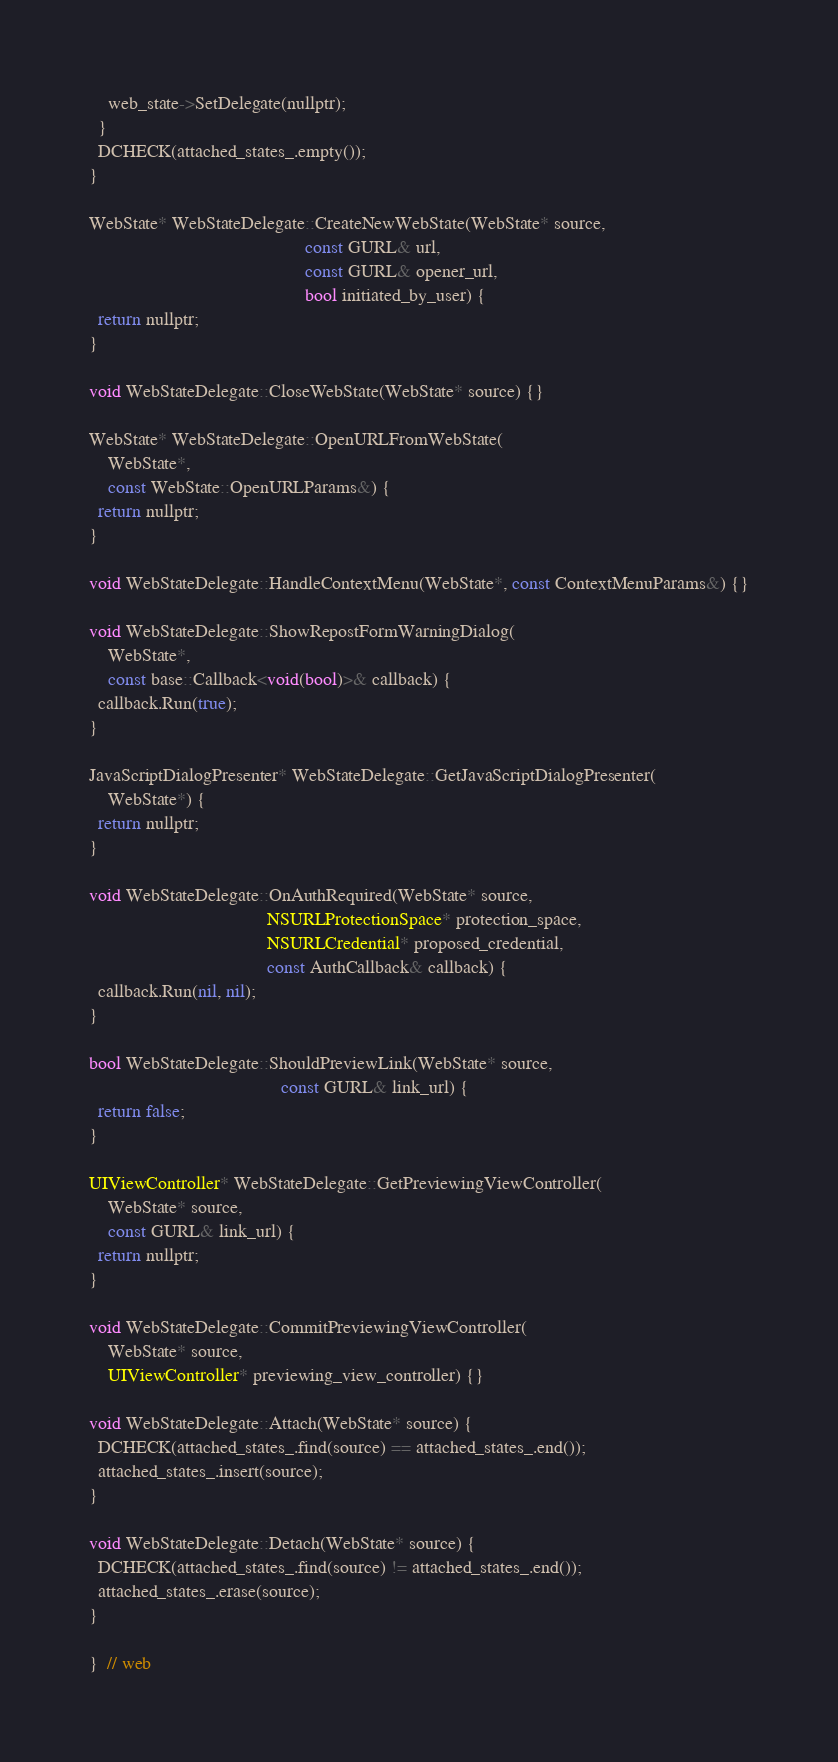Convert code to text. <code><loc_0><loc_0><loc_500><loc_500><_ObjectiveC_>    web_state->SetDelegate(nullptr);
  }
  DCHECK(attached_states_.empty());
}

WebState* WebStateDelegate::CreateNewWebState(WebState* source,
                                              const GURL& url,
                                              const GURL& opener_url,
                                              bool initiated_by_user) {
  return nullptr;
}

void WebStateDelegate::CloseWebState(WebState* source) {}

WebState* WebStateDelegate::OpenURLFromWebState(
    WebState*,
    const WebState::OpenURLParams&) {
  return nullptr;
}

void WebStateDelegate::HandleContextMenu(WebState*, const ContextMenuParams&) {}

void WebStateDelegate::ShowRepostFormWarningDialog(
    WebState*,
    const base::Callback<void(bool)>& callback) {
  callback.Run(true);
}

JavaScriptDialogPresenter* WebStateDelegate::GetJavaScriptDialogPresenter(
    WebState*) {
  return nullptr;
}

void WebStateDelegate::OnAuthRequired(WebState* source,
                                      NSURLProtectionSpace* protection_space,
                                      NSURLCredential* proposed_credential,
                                      const AuthCallback& callback) {
  callback.Run(nil, nil);
}

bool WebStateDelegate::ShouldPreviewLink(WebState* source,
                                         const GURL& link_url) {
  return false;
}

UIViewController* WebStateDelegate::GetPreviewingViewController(
    WebState* source,
    const GURL& link_url) {
  return nullptr;
}

void WebStateDelegate::CommitPreviewingViewController(
    WebState* source,
    UIViewController* previewing_view_controller) {}

void WebStateDelegate::Attach(WebState* source) {
  DCHECK(attached_states_.find(source) == attached_states_.end());
  attached_states_.insert(source);
}

void WebStateDelegate::Detach(WebState* source) {
  DCHECK(attached_states_.find(source) != attached_states_.end());
  attached_states_.erase(source);
}

}  // web
</code> 